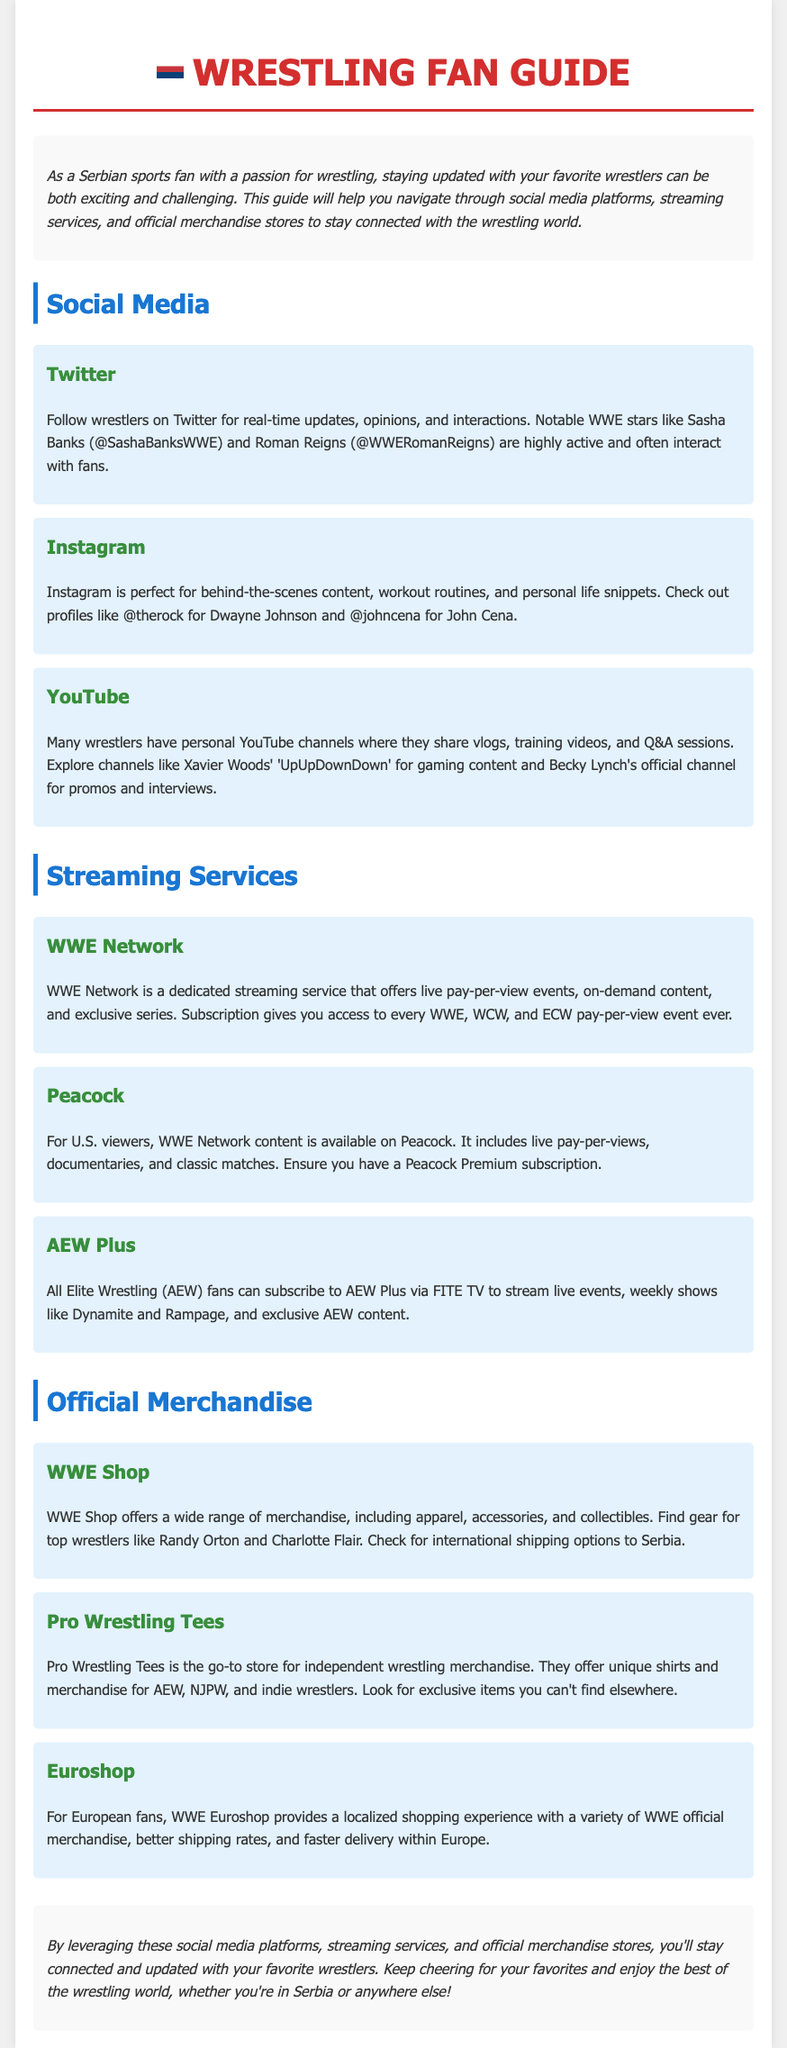What social media platform is highlighted for real-time updates? The document mentions Twitter as a platform where wrestlers provide real-time updates.
Answer: Twitter Which streaming service includes live pay-per-view events? The WWE Network is specified as offering live pay-per-view events.
Answer: WWE Network What is the primary merchandise store for independent wrestling? Pro Wrestling Tees is described as the go-to store for independent wrestling merchandise.
Answer: Pro Wrestling Tees Name one notable WWE star active on Twitter. The document lists Sasha Banks and Roman Reigns as notable WWE stars on Twitter.
Answer: Sasha Banks What subscription is required for WWE Network content on Peacock? The document states that a Peacock Premium subscription is necessary for WWE Network content on Peacock.
Answer: Peacock Premium How does WWE Euroshop benefit European fans? The document explains that WWE Euroshop provides a localized shopping experience with better shipping rates.
Answer: Better shipping rates Which famous wrestler is associated with the Instagram handle @therock? The document identifies Dwayne Johnson with the Instagram handle @therock.
Answer: Dwayne Johnson What type of content can be found on Xavier Woods' YouTube channel? The document mentions that Xavier Woods shares gaming content on his YouTube channel 'UpUpDownDown'.
Answer: Gaming content What exclusive benefit does AEW Plus provide its subscribers? The document indicates that AEW Plus allows subscribers to stream live events and exclusive AEW content.
Answer: Live events and exclusive content 